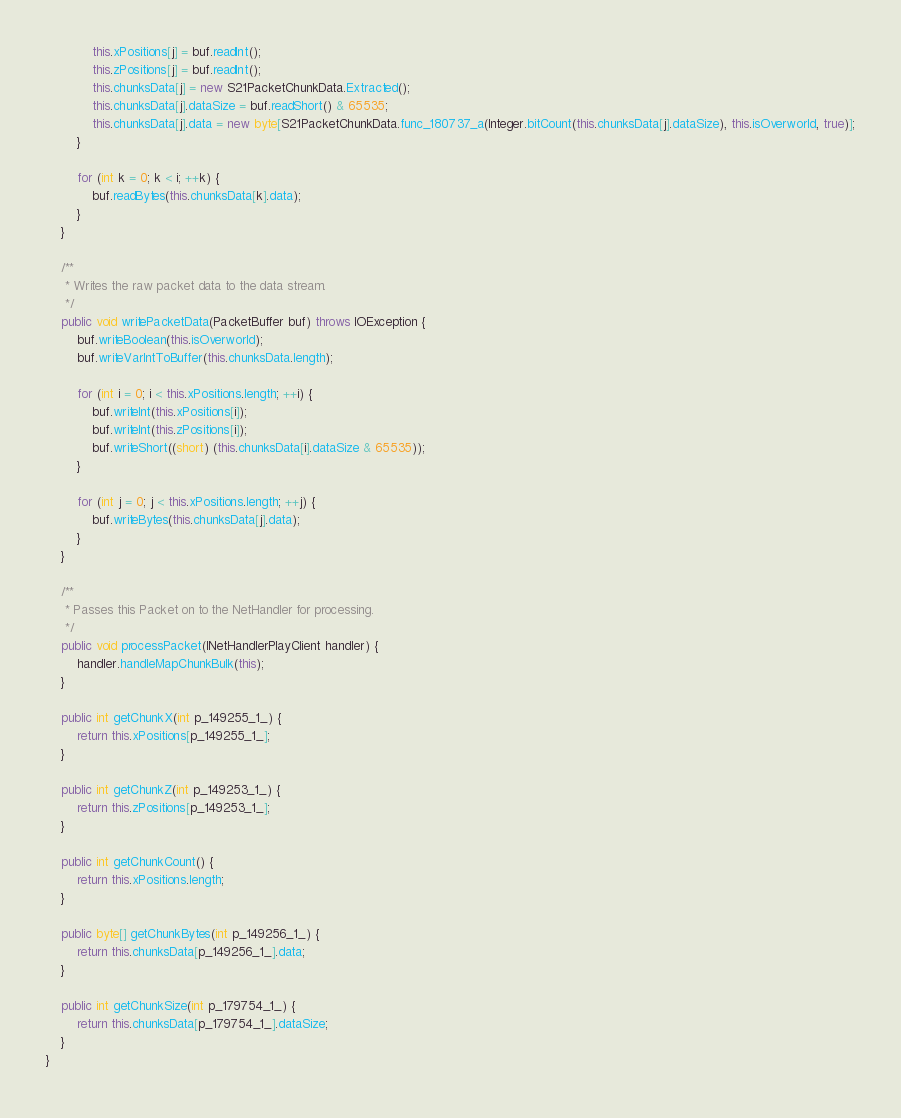<code> <loc_0><loc_0><loc_500><loc_500><_Java_>			this.xPositions[j] = buf.readInt();
			this.zPositions[j] = buf.readInt();
			this.chunksData[j] = new S21PacketChunkData.Extracted();
			this.chunksData[j].dataSize = buf.readShort() & 65535;
			this.chunksData[j].data = new byte[S21PacketChunkData.func_180737_a(Integer.bitCount(this.chunksData[j].dataSize), this.isOverworld, true)];
		}

		for (int k = 0; k < i; ++k) {
			buf.readBytes(this.chunksData[k].data);
		}
	}

	/**
	 * Writes the raw packet data to the data stream.
	 */
	public void writePacketData(PacketBuffer buf) throws IOException {
		buf.writeBoolean(this.isOverworld);
		buf.writeVarIntToBuffer(this.chunksData.length);

		for (int i = 0; i < this.xPositions.length; ++i) {
			buf.writeInt(this.xPositions[i]);
			buf.writeInt(this.zPositions[i]);
			buf.writeShort((short) (this.chunksData[i].dataSize & 65535));
		}

		for (int j = 0; j < this.xPositions.length; ++j) {
			buf.writeBytes(this.chunksData[j].data);
		}
	}

	/**
	 * Passes this Packet on to the NetHandler for processing.
	 */
	public void processPacket(INetHandlerPlayClient handler) {
		handler.handleMapChunkBulk(this);
	}

	public int getChunkX(int p_149255_1_) {
		return this.xPositions[p_149255_1_];
	}

	public int getChunkZ(int p_149253_1_) {
		return this.zPositions[p_149253_1_];
	}

	public int getChunkCount() {
		return this.xPositions.length;
	}

	public byte[] getChunkBytes(int p_149256_1_) {
		return this.chunksData[p_149256_1_].data;
	}

	public int getChunkSize(int p_179754_1_) {
		return this.chunksData[p_179754_1_].dataSize;
	}
}
</code> 